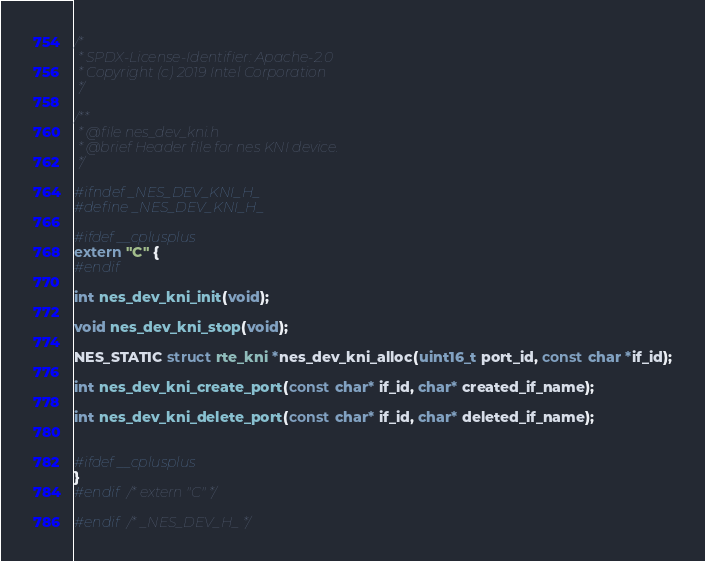<code> <loc_0><loc_0><loc_500><loc_500><_C_>/*
 * SPDX-License-Identifier: Apache-2.0
 * Copyright (c) 2019 Intel Corporation
 */

/**
 * @file nes_dev_kni.h
 * @brief Header file for nes KNI device.
 */

#ifndef _NES_DEV_KNI_H_
#define _NES_DEV_KNI_H_

#ifdef __cplusplus
extern "C" {
#endif

int nes_dev_kni_init(void);

void nes_dev_kni_stop(void);

NES_STATIC struct rte_kni *nes_dev_kni_alloc(uint16_t port_id, const char *if_id);

int nes_dev_kni_create_port(const char* if_id, char* created_if_name);

int nes_dev_kni_delete_port(const char* if_id, char* deleted_if_name);


#ifdef __cplusplus
}
#endif /* extern "C" */

#endif /* _NES_DEV_H_ */
</code> 